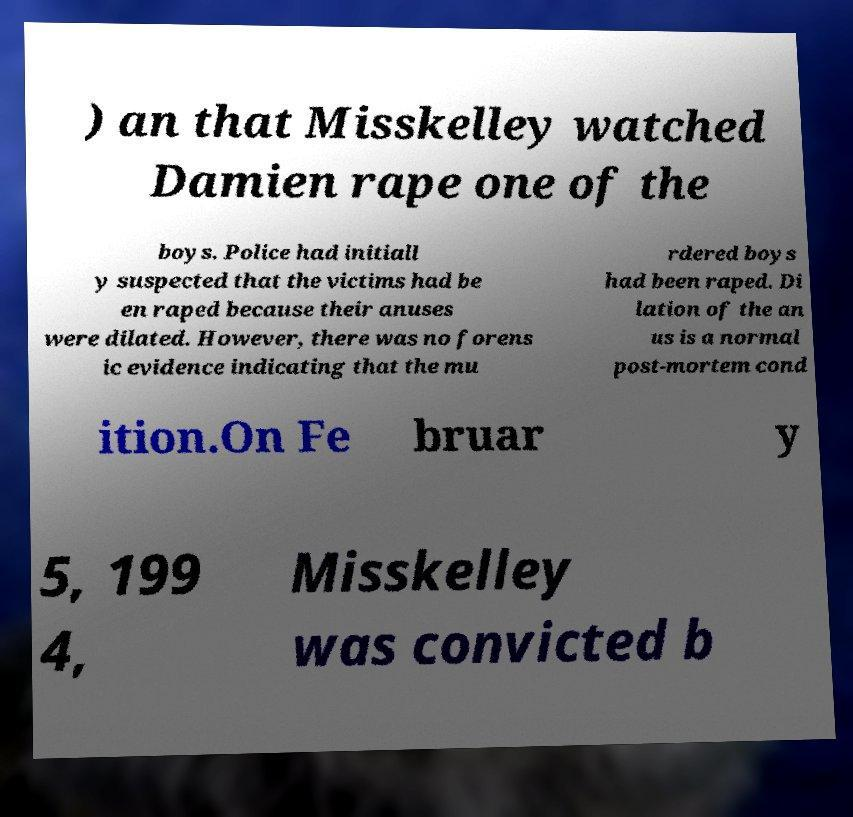There's text embedded in this image that I need extracted. Can you transcribe it verbatim? ) an that Misskelley watched Damien rape one of the boys. Police had initiall y suspected that the victims had be en raped because their anuses were dilated. However, there was no forens ic evidence indicating that the mu rdered boys had been raped. Di lation of the an us is a normal post-mortem cond ition.On Fe bruar y 5, 199 4, Misskelley was convicted b 